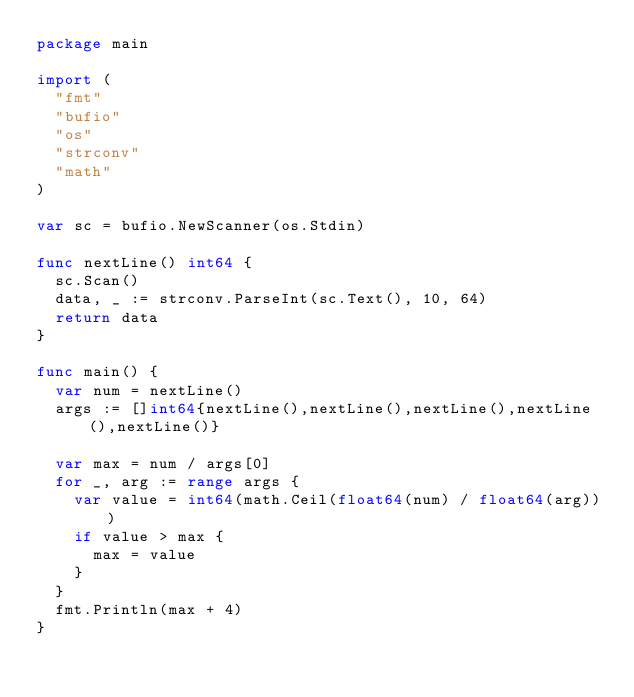Convert code to text. <code><loc_0><loc_0><loc_500><loc_500><_Go_>package main

import (
  "fmt"
  "bufio"
  "os"
  "strconv"
  "math"
)

var sc = bufio.NewScanner(os.Stdin)

func nextLine() int64 {
  sc.Scan()
  data, _ := strconv.ParseInt(sc.Text(), 10, 64)
  return data
}

func main() {
  var num = nextLine()
  args := []int64{nextLine(),nextLine(),nextLine(),nextLine(),nextLine()}

  var max = num / args[0]
  for _, arg := range args {
    var value = int64(math.Ceil(float64(num) / float64(arg)))
    if value > max {
      max = value
    }
  }
  fmt.Println(max + 4)
}

</code> 